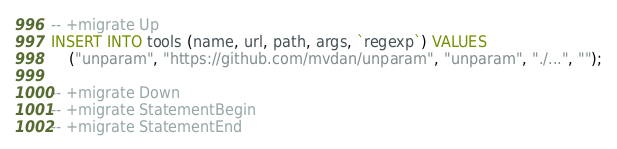Convert code to text. <code><loc_0><loc_0><loc_500><loc_500><_SQL_>-- +migrate Up
INSERT INTO tools (name, url, path, args, `regexp`) VALUES
    ("unparam", "https://github.com/mvdan/unparam", "unparam", "./...", "");

-- +migrate Down
-- +migrate StatementBegin
-- +migrate StatementEnd
</code> 